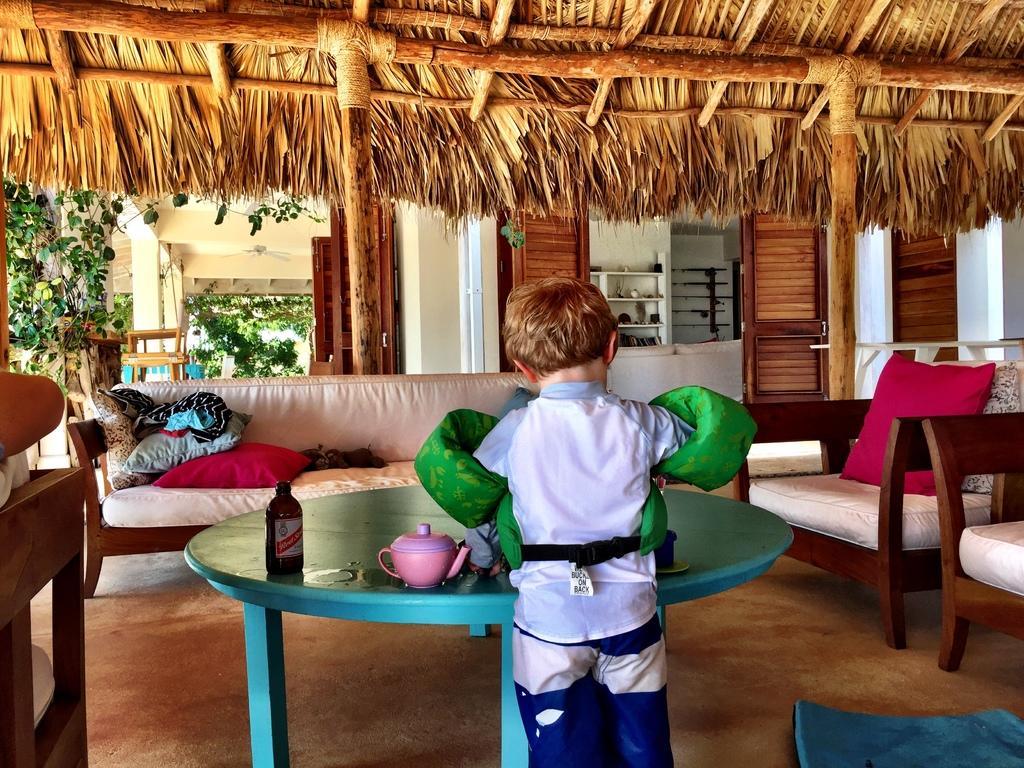In one or two sentences, can you explain what this image depicts? In this picture there is a boy who is playing with his toys, standing near the table and there is a sofa at the right side of the image and a table at the left side of the image, there are some doors at the right and left side of the image and there is a rug on the floor at the right side of the image. 